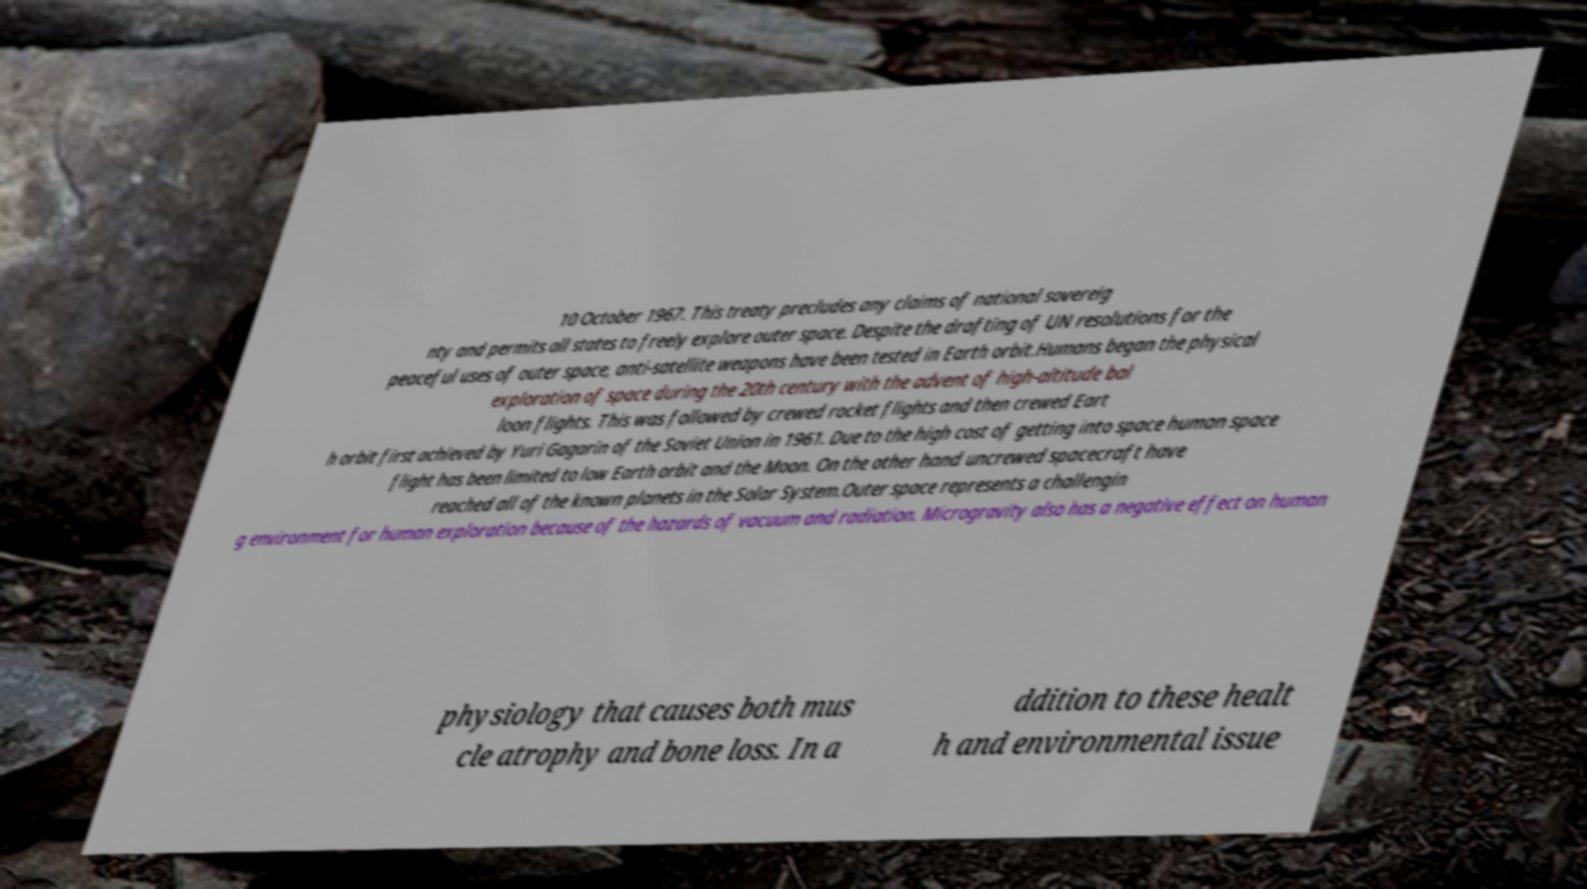Please read and relay the text visible in this image. What does it say? 10 October 1967. This treaty precludes any claims of national sovereig nty and permits all states to freely explore outer space. Despite the drafting of UN resolutions for the peaceful uses of outer space, anti-satellite weapons have been tested in Earth orbit.Humans began the physical exploration of space during the 20th century with the advent of high-altitude bal loon flights. This was followed by crewed rocket flights and then crewed Eart h orbit first achieved by Yuri Gagarin of the Soviet Union in 1961. Due to the high cost of getting into space human space flight has been limited to low Earth orbit and the Moon. On the other hand uncrewed spacecraft have reached all of the known planets in the Solar System.Outer space represents a challengin g environment for human exploration because of the hazards of vacuum and radiation. Microgravity also has a negative effect on human physiology that causes both mus cle atrophy and bone loss. In a ddition to these healt h and environmental issue 